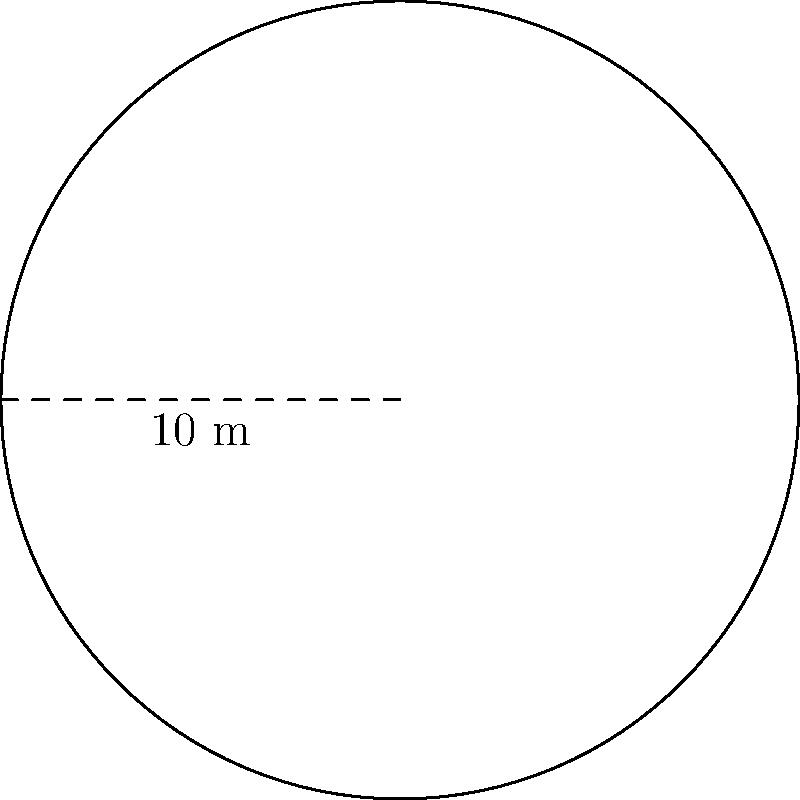You're planning to resurface the floor of a circular garage. The diameter of the garage is 10 meters. How many square meters of flooring material do you need to cover the entire garage floor? Let's break this down step-by-step:

1. We're given the diameter of the garage, which is 10 meters.

2. To find the area, we need the radius. The radius is half the diameter:
   $r = 10 \div 2 = 5$ meters

3. The formula for the area of a circle is:
   $A = \pi r^2$

4. Let's plug in our radius:
   $A = \pi (5)^2$

5. Simplify:
   $A = \pi (25)$

6. Use 3.14 as an approximation for π:
   $A \approx 3.14 \times 25 = 78.5$ square meters

7. Since we're dealing with flooring, it's best to round up to ensure we have enough material:
   $A \approx 79$ square meters
Answer: 79 square meters 